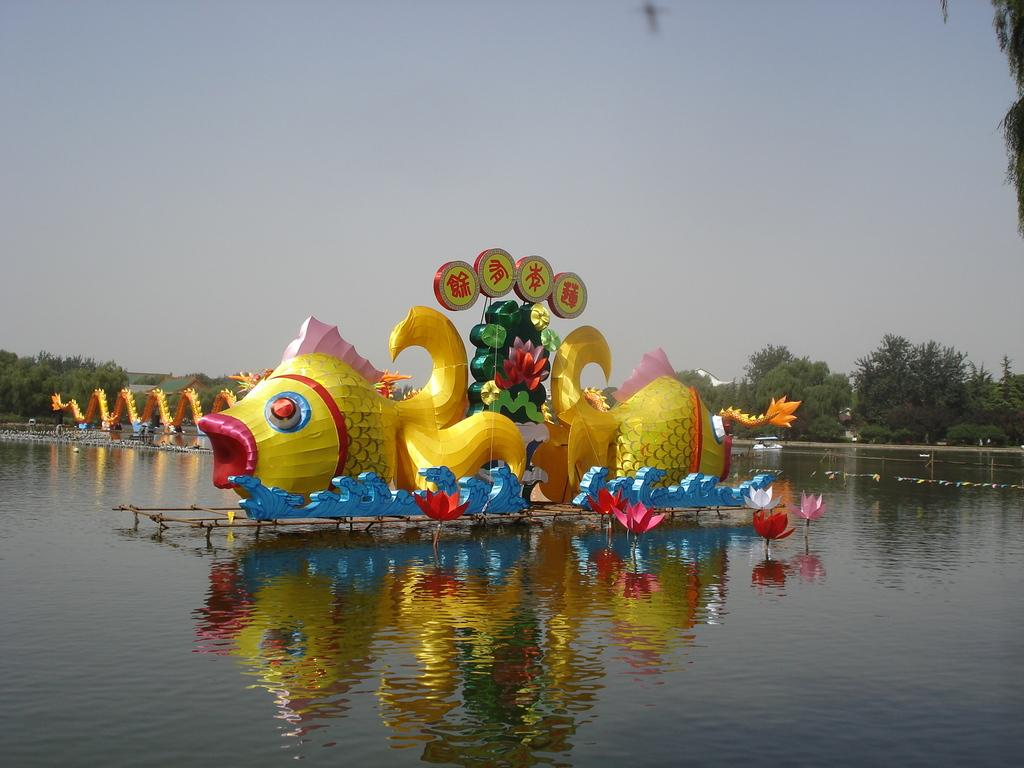Where was the image taken? The image is clicked outside. What is the main subject in the middle of the image? There is a boat in the middle of the image. What is visible at the bottom of the image? There is water visible at the bottom of the image. What type of vegetation is present in the middle of the image? There are trees in the middle of the image. What is visible at the top of the image? The sky is visible at the top of the image. What type of yoke can be seen in the image? There is no yoke present in the image. Is the image taken during the night or day? The provided facts do not mention the time of day, so it cannot be determined if the image was taken during the night or day. 